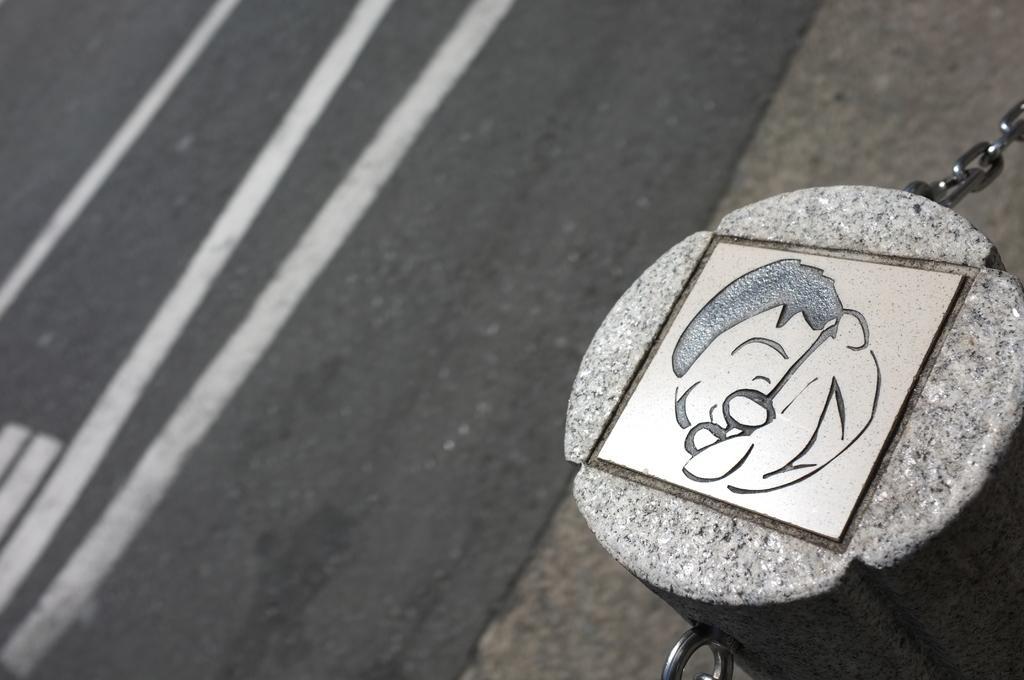Please provide a concise description of this image. In this image, we can see a stone with an image. We can see some chains and the ground. 